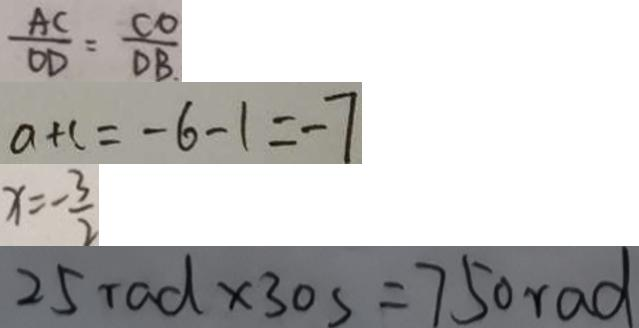<formula> <loc_0><loc_0><loc_500><loc_500>\frac { A C } { O D } = \frac { C O } { D B } _ { \cdot } 
 a + c = - 6 - 1 = - 7 
 x = - \frac { 3 } { 2 } 
 2 5 r a d \times 3 0 s = 7 5 0 r a d</formula> 